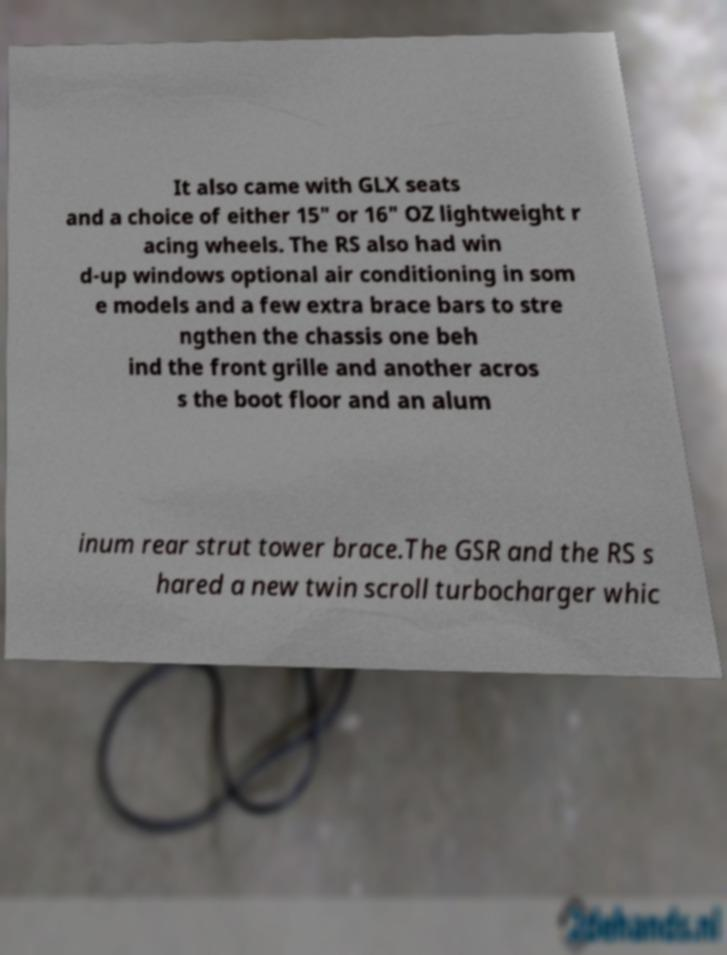Could you extract and type out the text from this image? It also came with GLX seats and a choice of either 15" or 16" OZ lightweight r acing wheels. The RS also had win d-up windows optional air conditioning in som e models and a few extra brace bars to stre ngthen the chassis one beh ind the front grille and another acros s the boot floor and an alum inum rear strut tower brace.The GSR and the RS s hared a new twin scroll turbocharger whic 